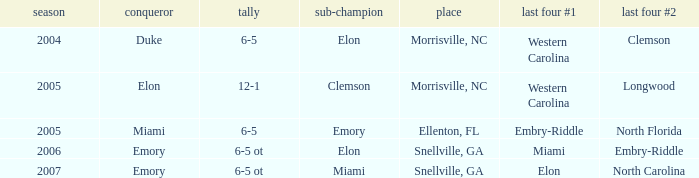List the scores of all games when Miami were listed as the first Semi finalist 6-5 ot. 